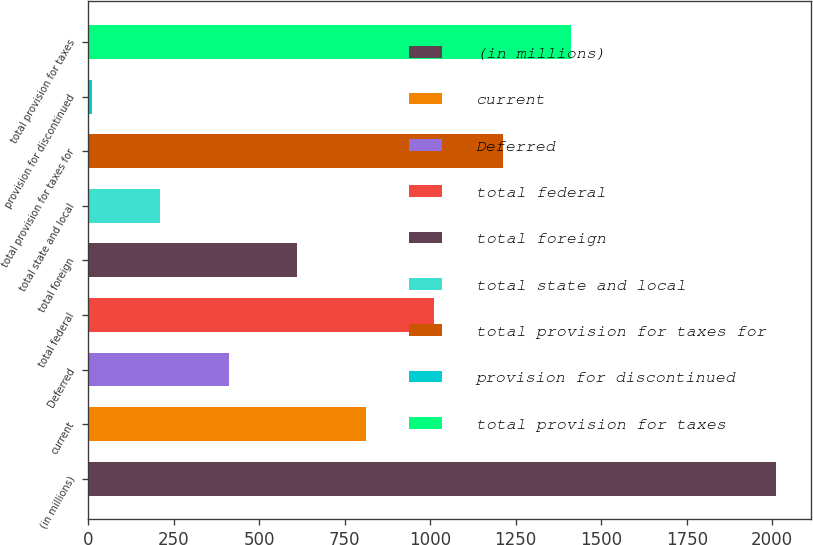Convert chart to OTSL. <chart><loc_0><loc_0><loc_500><loc_500><bar_chart><fcel>(in millions)<fcel>current<fcel>Deferred<fcel>total federal<fcel>total foreign<fcel>total state and local<fcel>total provision for taxes for<fcel>provision for discontinued<fcel>total provision for taxes<nl><fcel>2012<fcel>811.4<fcel>411.2<fcel>1011.5<fcel>611.3<fcel>211.1<fcel>1211.6<fcel>11<fcel>1411.7<nl></chart> 